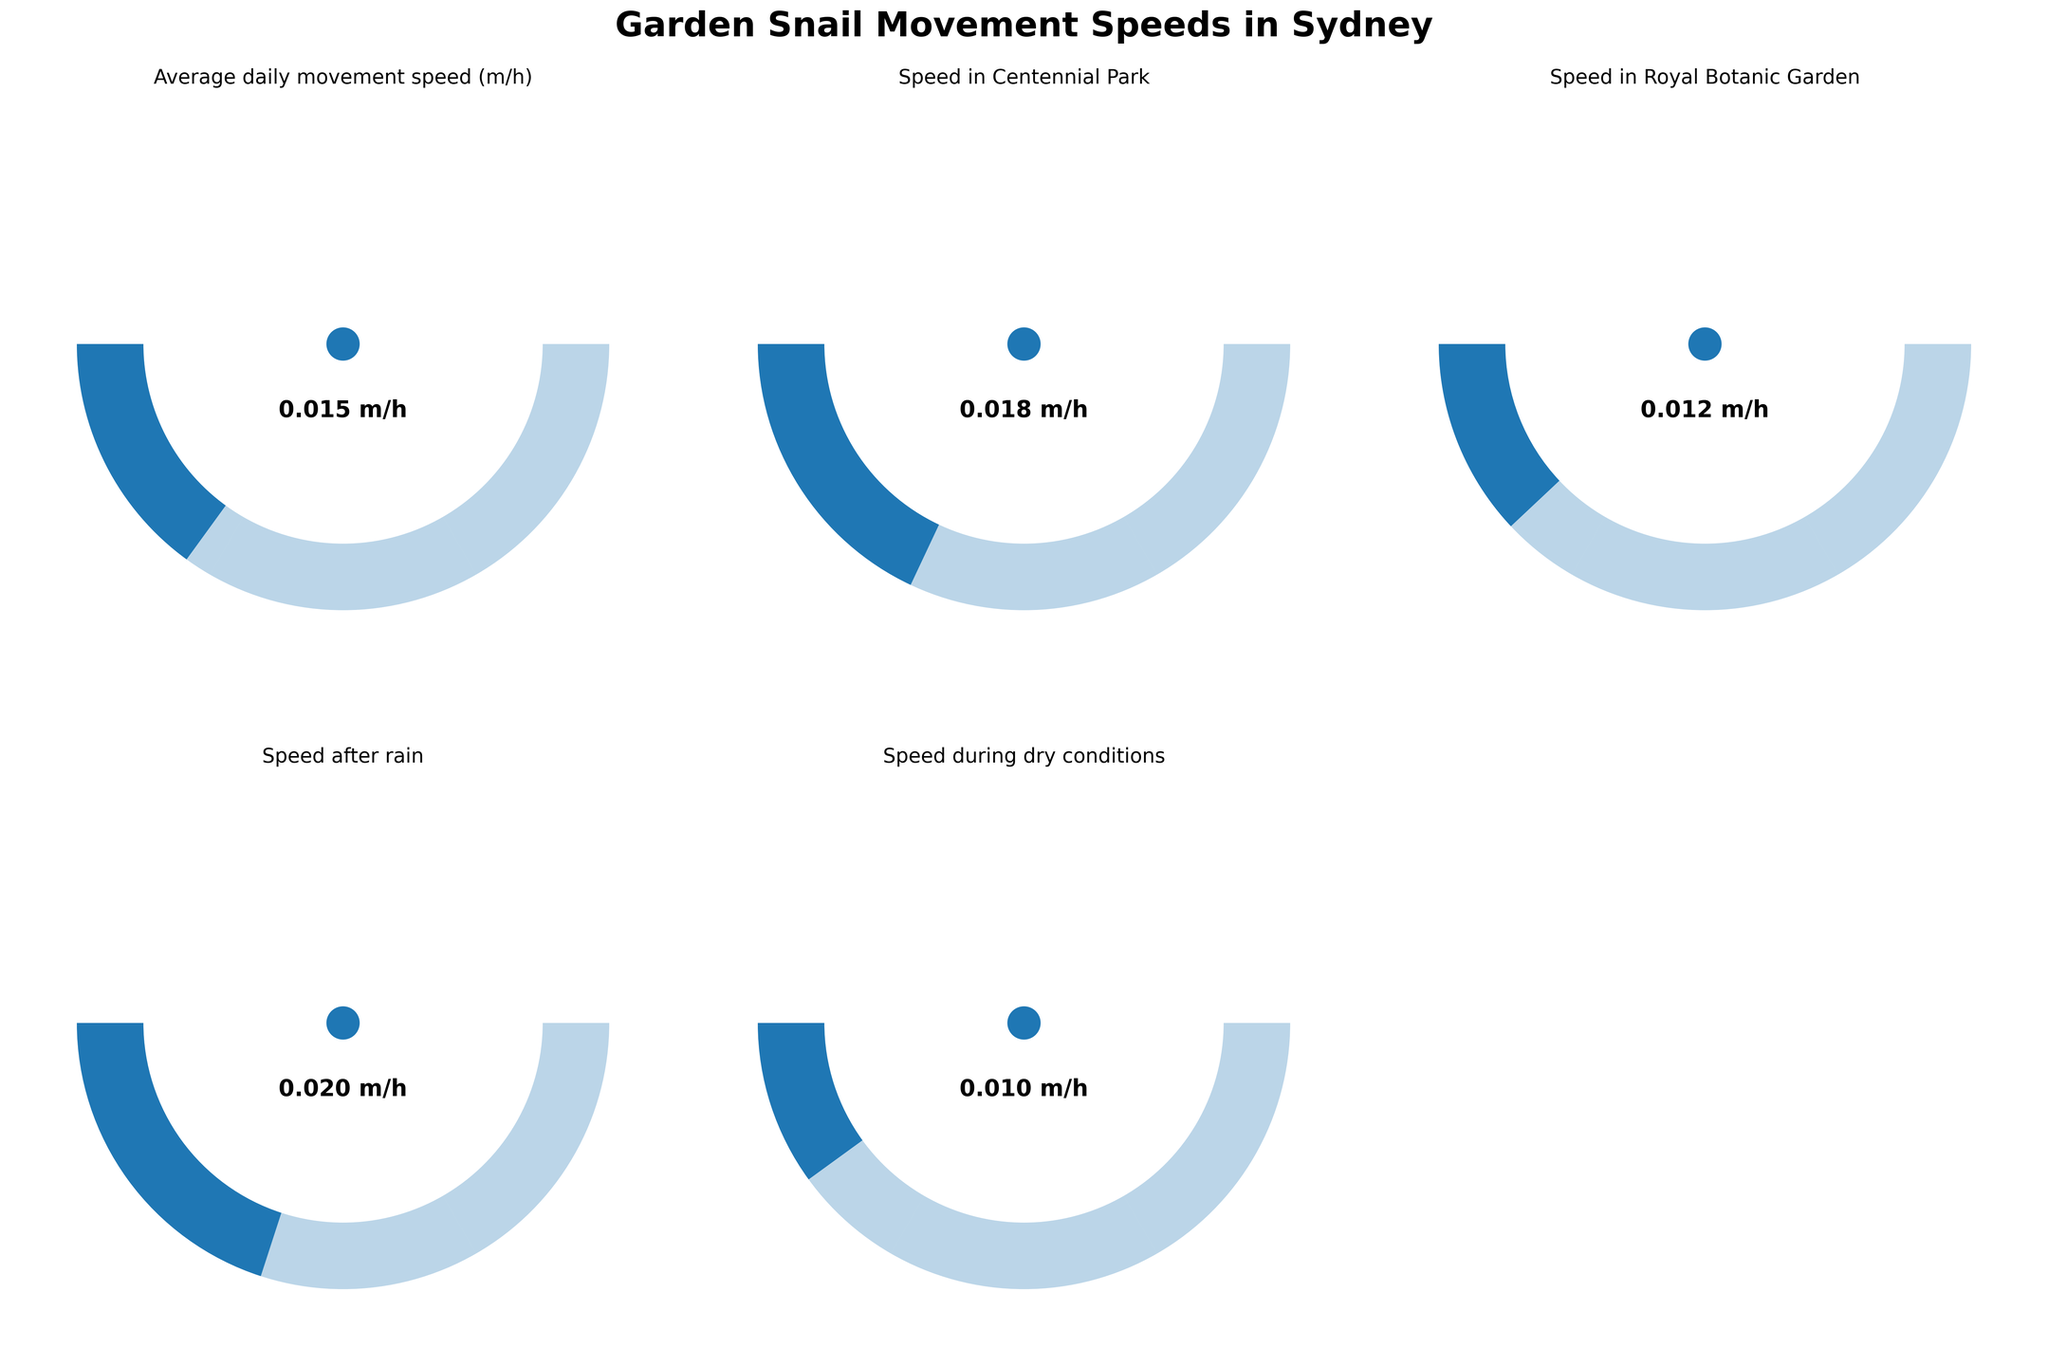How many gauge charts are displayed in the figure? There are six data points provided in the data, and since each gauge chart displays one data point, the figure displays six gauge charts. However, for visual balance, one gauge chart (in the second row, third column) is removed.
Answer: Six gauge charts What is the title of the figure? The title of the figure is prominently displayed at the top of the figure.
Answer: Garden Snail Movement Speeds in Sydney What is the highest average daily movement speed recorded in the figure? By looking at the gauge charts, compare the values displayed. The highest value visible is 0.020 m/h.
Answer: 0.020 m/h What environmental condition corresponds to the highest snail movement speed? Check the labels on the gauge charts and compare them with the highest speed identified. The highest speed is 0.020 m/h and corresponds to the "Speed after rain" chart.
Answer: Speed after rain What is the difference in movement speed between snails in the Royal Botanic Garden and during dry conditions? Extract the values from the respective gauge charts. The Royal Botanic Garden speed is 0.012 m/h, and during dry conditions is 0.010 m/h. Subtract the latter from the former: 0.012 - 0.010 = 0.002 m/h.
Answer: 0.002 m/h Which location has the lowest average snail speed? Identify the lowest value by comparing all the gauge charts. The lowest value is 0.010 m/h. The corresponding location is "Speed during dry conditions."
Answer: Speed during dry conditions Which two locations or conditions have the closest average snail speed? Compare the values of all the gauge charts and identify the two closest. "Speed in Centennial Park" (0.018 m/h) and "Speed after rain" (0.020 m/h) are the closest, with a difference of 0.002 m/h.
Answer: Speed in Centennial Park and Speed after rain How does the average snail speed in Centennial Park compare to that in the Royal Botanic Garden? Compare the values of these two gauge charts. The speed in Centennial Park is 0.018 m/h while in the Royal Botanic Garden is 0.012 m/h. Centennial Park has a higher speed by 0.006 m/h.
Answer: Centennial Park has a higher speed by 0.006 m/h What is the average of all the recorded snail speeds? To compute the average, sum all the speeds and divide by the count. The speeds are 0.015, 0.018, 0.012, 0.020, and 0.010. The sum is 0.075 and there are 5 data points. Average = 0.075/5 = 0.015 m/h.
Answer: 0.015 m/h What are the colors used in the gauge charts to represent different speed ranges? The gauge charts use a gradient of three colors across the speed range. The colors are light beige, sandy yellow, and gold-brown (described without using coding terms).
Answer: Light beige, sandy yellow, gold-brown 